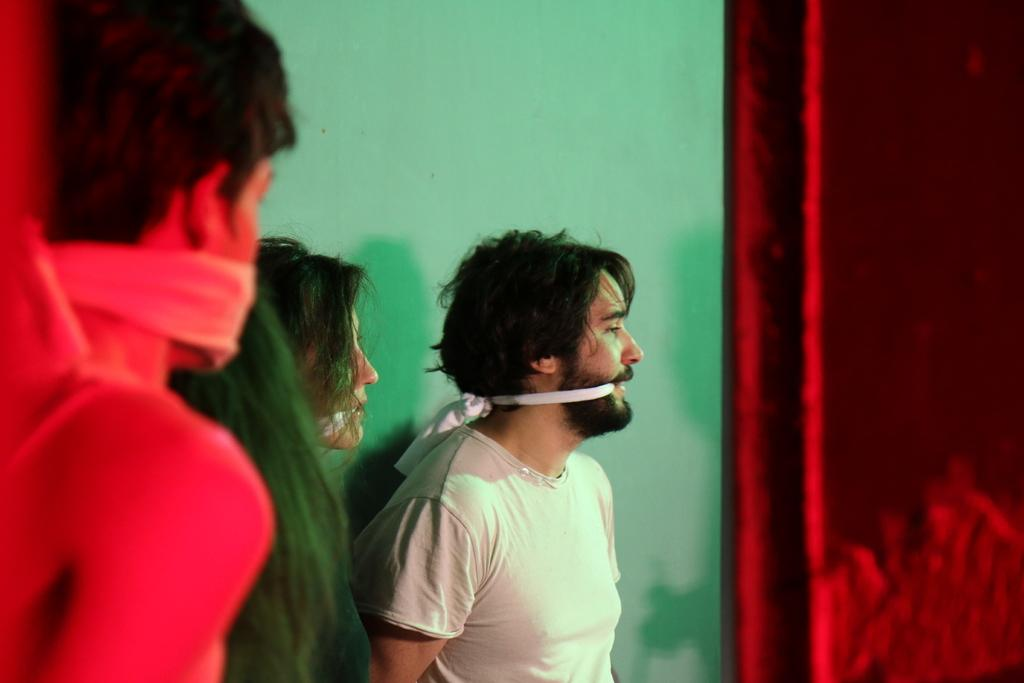How many people are present in the image? There are three persons standing in the image. What can be seen in the background of the image? There is a wall in the background of the image. What is on the right side of the image? There is a curtain on the right side of the image. What type of pump is being used by the queen in the image? There is no queen or pump present in the image. 